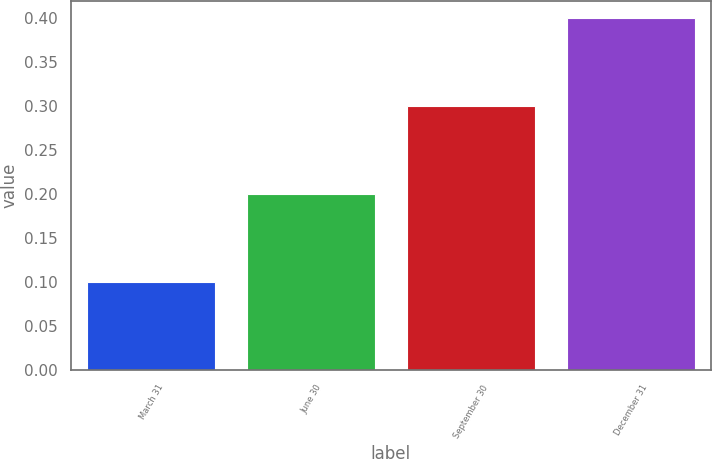Convert chart to OTSL. <chart><loc_0><loc_0><loc_500><loc_500><bar_chart><fcel>March 31<fcel>June 30<fcel>September 30<fcel>December 31<nl><fcel>0.1<fcel>0.2<fcel>0.3<fcel>0.4<nl></chart> 